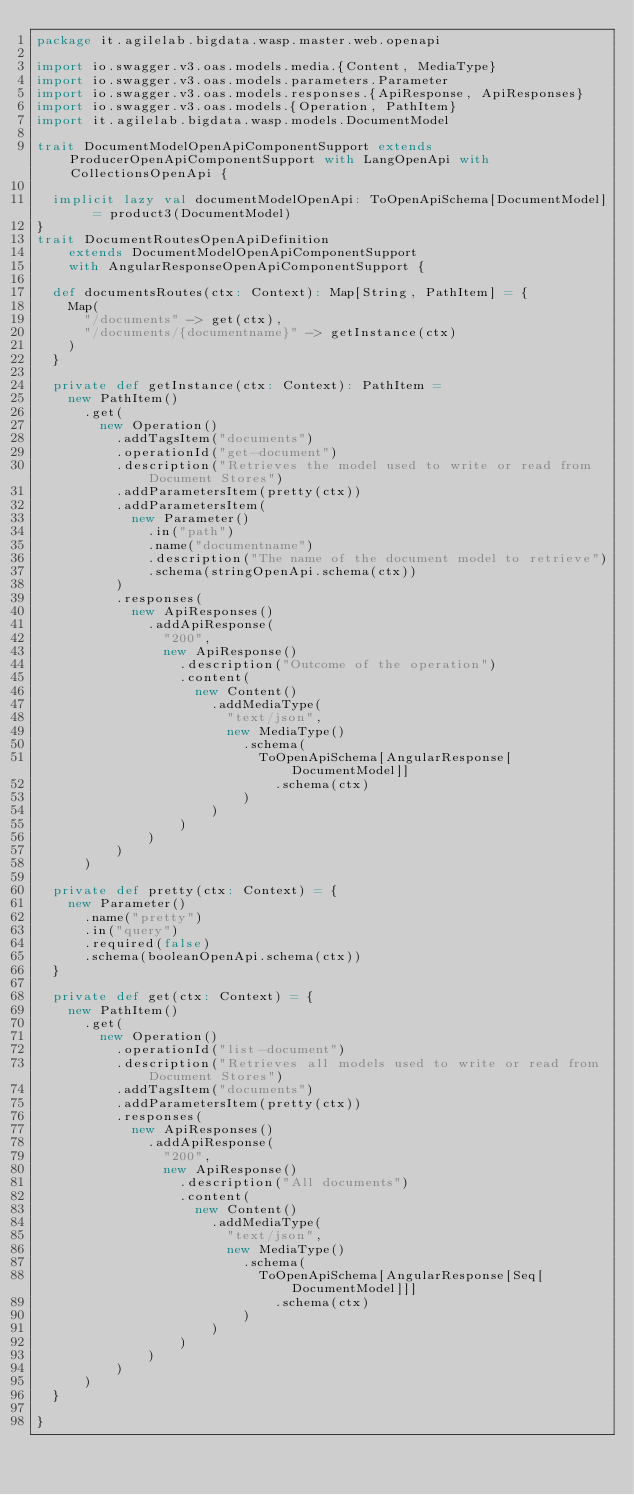Convert code to text. <code><loc_0><loc_0><loc_500><loc_500><_Scala_>package it.agilelab.bigdata.wasp.master.web.openapi

import io.swagger.v3.oas.models.media.{Content, MediaType}
import io.swagger.v3.oas.models.parameters.Parameter
import io.swagger.v3.oas.models.responses.{ApiResponse, ApiResponses}
import io.swagger.v3.oas.models.{Operation, PathItem}
import it.agilelab.bigdata.wasp.models.DocumentModel

trait DocumentModelOpenApiComponentSupport extends ProducerOpenApiComponentSupport with LangOpenApi with CollectionsOpenApi {

  implicit lazy val documentModelOpenApi: ToOpenApiSchema[DocumentModel] = product3(DocumentModel)
}
trait DocumentRoutesOpenApiDefinition
    extends DocumentModelOpenApiComponentSupport
    with AngularResponseOpenApiComponentSupport {

  def documentsRoutes(ctx: Context): Map[String, PathItem] = {
    Map(
      "/documents" -> get(ctx),
      "/documents/{documentname}" -> getInstance(ctx)
    )
  }

  private def getInstance(ctx: Context): PathItem =
    new PathItem()
      .get(
        new Operation()
          .addTagsItem("documents")
          .operationId("get-document")
          .description("Retrieves the model used to write or read from Document Stores")
          .addParametersItem(pretty(ctx))
          .addParametersItem(
            new Parameter()
              .in("path")
              .name("documentname")
              .description("The name of the document model to retrieve")
              .schema(stringOpenApi.schema(ctx))
          )
          .responses(
            new ApiResponses()
              .addApiResponse(
                "200",
                new ApiResponse()
                  .description("Outcome of the operation")
                  .content(
                    new Content()
                      .addMediaType(
                        "text/json",
                        new MediaType()
                          .schema(
                            ToOpenApiSchema[AngularResponse[DocumentModel]]
                              .schema(ctx)
                          )
                      )
                  )
              )
          )
      )

  private def pretty(ctx: Context) = {
    new Parameter()
      .name("pretty")
      .in("query")
      .required(false)
      .schema(booleanOpenApi.schema(ctx))
  }

  private def get(ctx: Context) = {
    new PathItem()
      .get(
        new Operation()
          .operationId("list-document")
          .description("Retrieves all models used to write or read from Document Stores")
          .addTagsItem("documents")
          .addParametersItem(pretty(ctx))
          .responses(
            new ApiResponses()
              .addApiResponse(
                "200",
                new ApiResponse()
                  .description("All documents")
                  .content(
                    new Content()
                      .addMediaType(
                        "text/json",
                        new MediaType()
                          .schema(
                            ToOpenApiSchema[AngularResponse[Seq[DocumentModel]]]
                              .schema(ctx)
                          )
                      )
                  )
              )
          )
      )
  }

}
</code> 